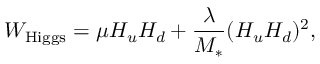<formula> <loc_0><loc_0><loc_500><loc_500>W _ { H i g g s } = \mu H _ { u } H _ { d } + { \frac { \lambda } { M _ { * } } } ( H _ { u } H _ { d } ) ^ { 2 } ,</formula> 